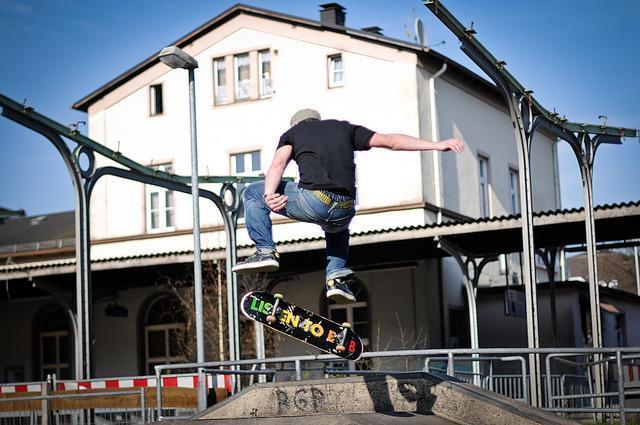How many teddy bears exist?
Give a very brief answer. 0. 